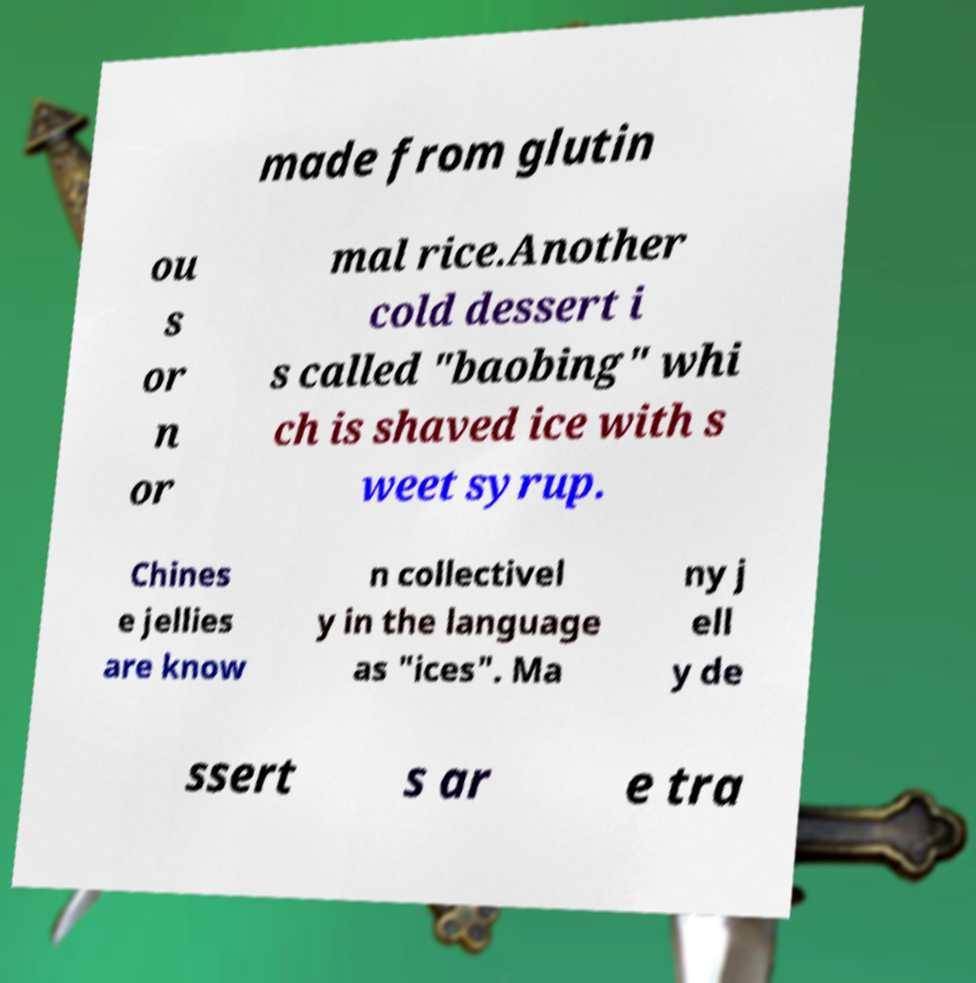There's text embedded in this image that I need extracted. Can you transcribe it verbatim? made from glutin ou s or n or mal rice.Another cold dessert i s called "baobing" whi ch is shaved ice with s weet syrup. Chines e jellies are know n collectivel y in the language as "ices". Ma ny j ell y de ssert s ar e tra 